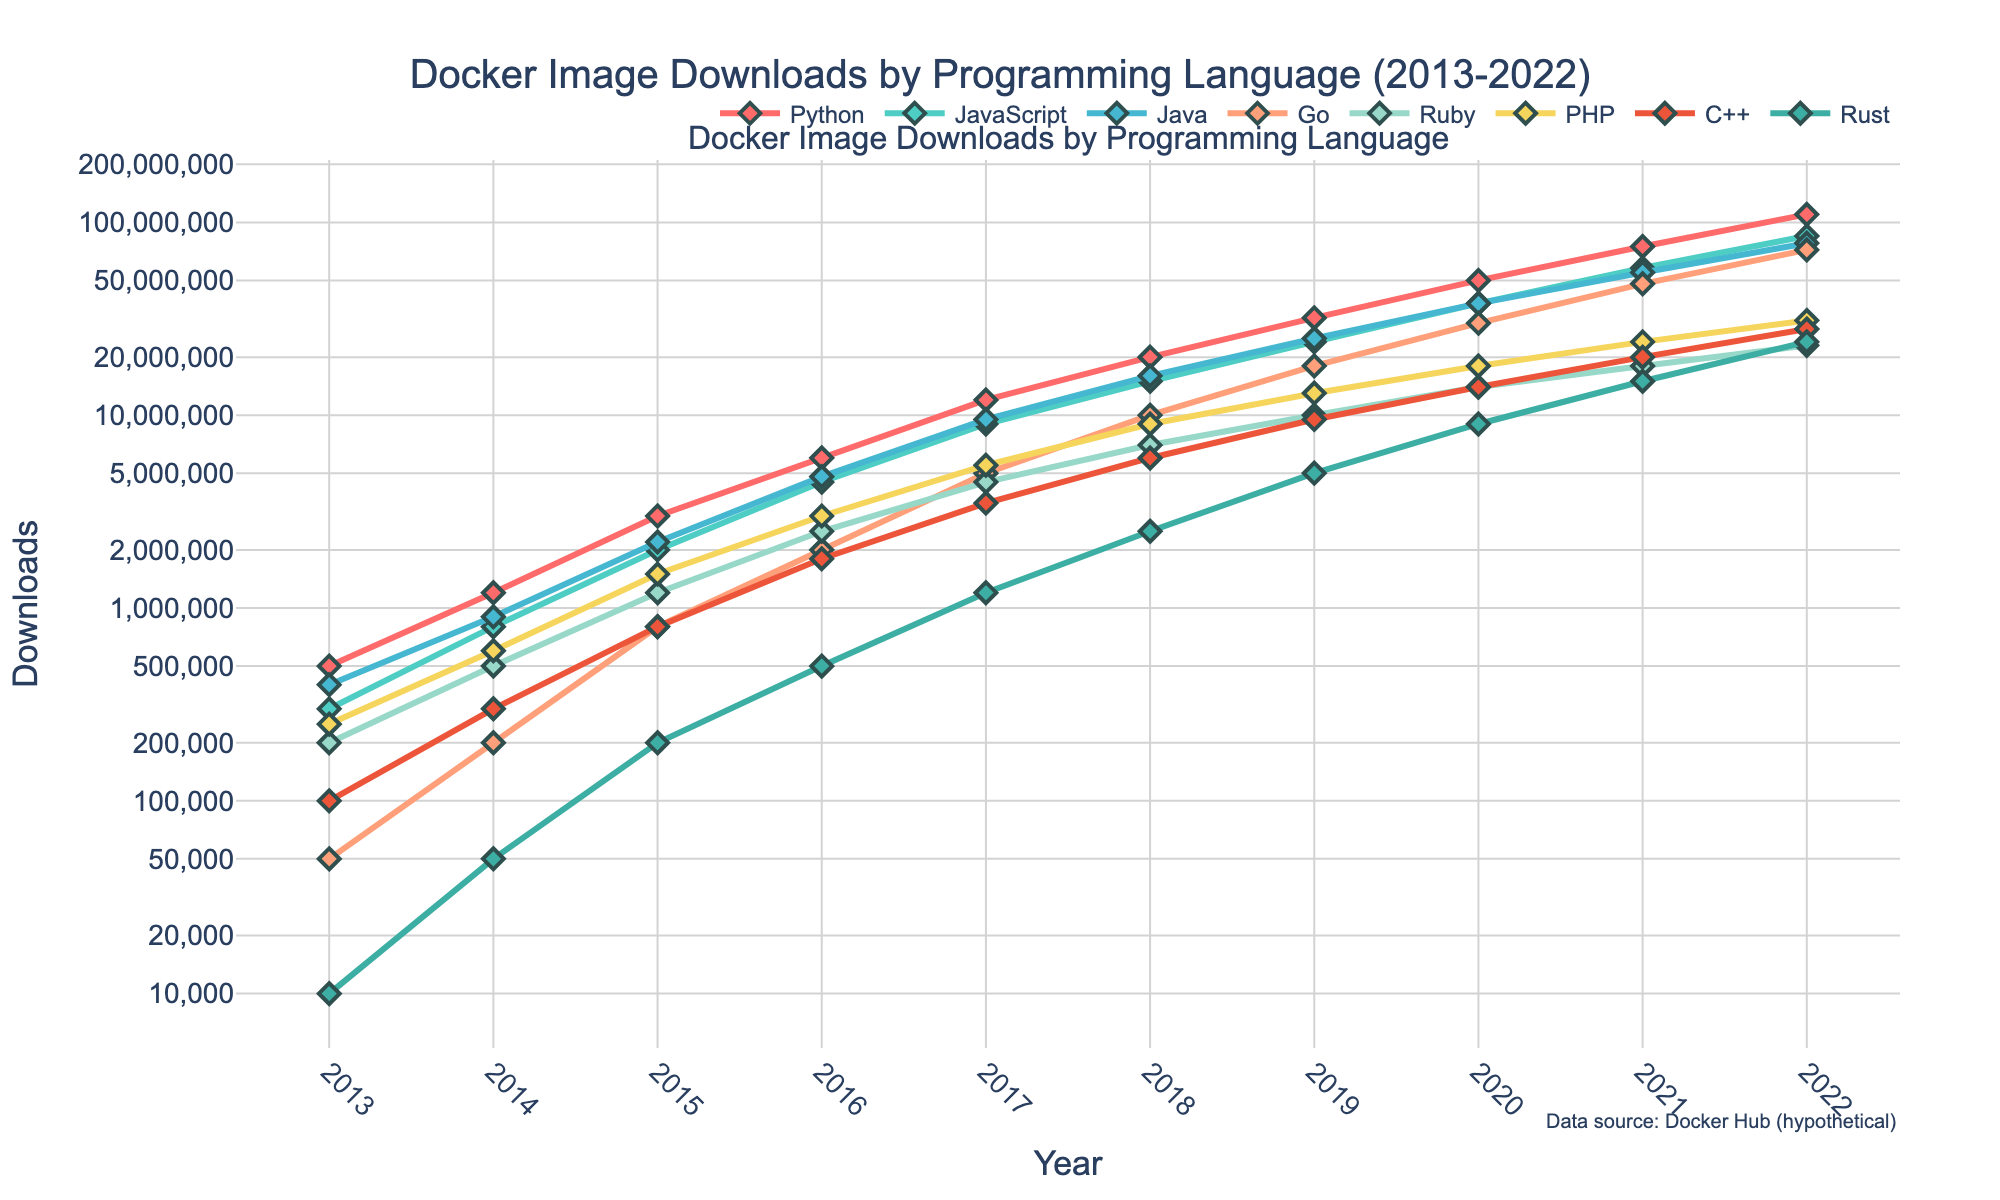What was the total number of Docker image downloads for Python and JavaScript in 2020? The download number for Python in 2020 is 50,000,000 and for JavaScript is 38,000,000. Adding them gives us: 50,000,000 + 38,000,000 = 88,000,000
Answer: 88,000,000 By how much did the downloads of Go images increase from 2018 to 2021? The downloads for Go in 2018 were 10,000,000 and in 2021 were 48,000,000. The increase is calculated by subtracting the 2018 value from the 2021 value: 48,000,000 - 10,000,000 = 38,000,000
Answer: 38,000,000 Which programming language had the most downloads in 2022? By looking at the values for 2022, Python has the highest download count with 110,000,000 downloads
Answer: Python How did the growth in downloads for Rust compare to C++ from 2015 to 2019? In 2015, Rust had 200,000 downloads and C++ had 800,000. In 2019, Rust had 5,000,000 downloads and C++ had 9,500,000. The growth for Rust can be computed as 5,000,000 - 200,000 = 4,800,000 while for C++ it is 9,500,000 - 800,000 = 8,700,000. Comparing these, 8,700,000 is greater than 4,800,000
Answer: Growth for C++ was greater What is the average number of downloads for Ruby images between 2014 and 2017 inclusive? Ruby download numbers from 2014 to 2017 are 500,000, 1,200,000, 2,500,000, and 4,500,000 respectively. Their sum is 500,000 + 1,200,000 + 2,500,000 + 4,500,000 = 8,700,000. The average is 8,700,000 / 4 = 2,175,000
Answer: 2,175,000 During which year did PHP first reach 10 million downloads? By observing the data, PHP first reached 10 million downloads in the year 2019 where it has 13,000,000 downloads
Answer: 2019 Which language experienced the smallest increase in downloads from 2019 to 2020? The increase for Python is 50,000,000 - 32,000,000 = 18,000,000; JavaScript 38,000,000 - 24,000,000 = 14,000,000; Java 38,000,000 - 25,000,000 = 13,000,000; Go 30,000,000 - 18,000,000 = 12,000,000; Ruby 14,000,000 - 10,000,000 = 4,000,000; PHP 18,000,000 - 13,000,000 = 5,000,000; C++ 14,000,000 - 9,500,000 = 4,500,000; Rust 9,000,000 - 5,000,000 = 4,000,000. The smallest increase is for Ruby and Rust, each increasing by 4,000,000
Answer: Ruby and Rust What color represents JavaScript in the plot? JavaScript is represented by the second color in the sequence, which is a shade of cyan
Answer: cyan 